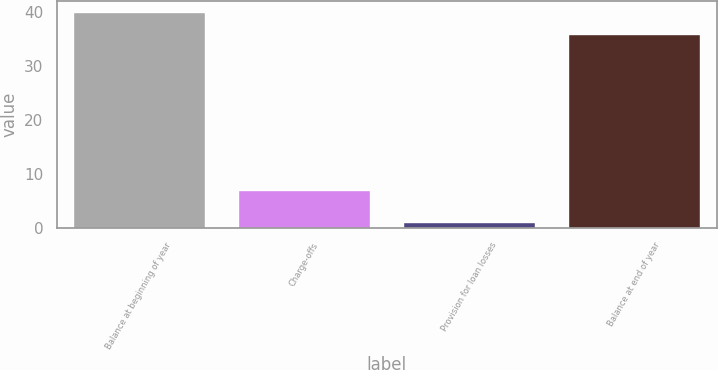Convert chart to OTSL. <chart><loc_0><loc_0><loc_500><loc_500><bar_chart><fcel>Balance at beginning of year<fcel>Charge-offs<fcel>Provision for loan losses<fcel>Balance at end of year<nl><fcel>40<fcel>7<fcel>1<fcel>36<nl></chart> 